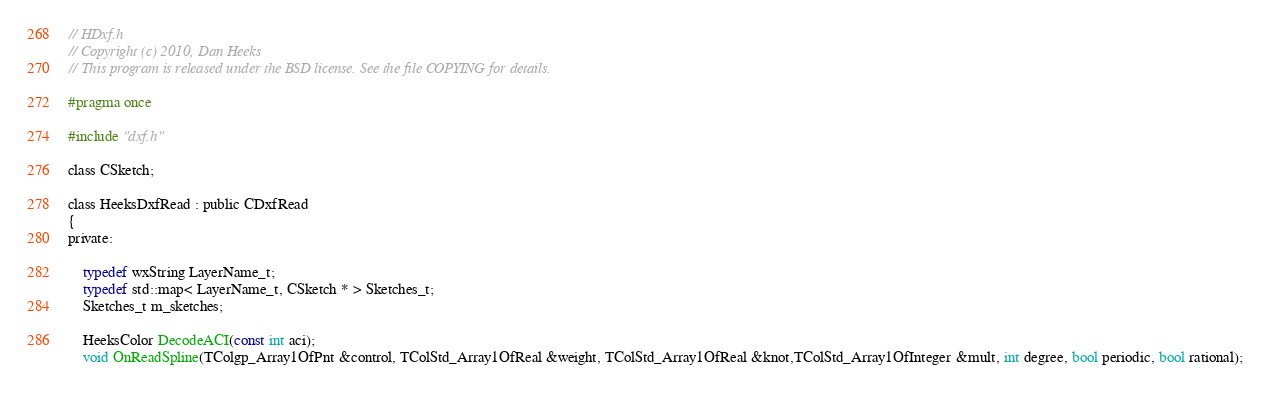<code> <loc_0><loc_0><loc_500><loc_500><_C_>// HDxf.h
// Copyright (c) 2010, Dan Heeks
// This program is released under the BSD license. See the file COPYING for details.

#pragma once

#include "dxf.h"

class CSketch;

class HeeksDxfRead : public CDxfRead
{
private:

    typedef wxString LayerName_t;
	typedef std::map< LayerName_t, CSketch * > Sketches_t;
	Sketches_t m_sketches;

	HeeksColor DecodeACI(const int aci);
	void OnReadSpline(TColgp_Array1OfPnt &control, TColStd_Array1OfReal &weight, TColStd_Array1OfReal &knot,TColStd_Array1OfInteger &mult, int degree, bool periodic, bool rational);</code> 